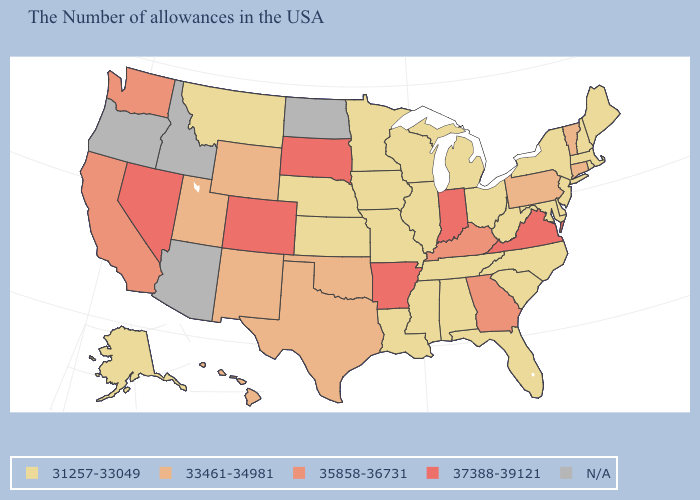Among the states that border West Virginia , does Virginia have the highest value?
Concise answer only. Yes. What is the value of Maryland?
Answer briefly. 31257-33049. How many symbols are there in the legend?
Be succinct. 5. Name the states that have a value in the range N/A?
Quick response, please. North Dakota, Arizona, Idaho, Oregon. What is the value of West Virginia?
Give a very brief answer. 31257-33049. What is the lowest value in the South?
Give a very brief answer. 31257-33049. What is the lowest value in the MidWest?
Quick response, please. 31257-33049. Does Pennsylvania have the highest value in the Northeast?
Quick response, please. Yes. What is the value of Arkansas?
Concise answer only. 37388-39121. Name the states that have a value in the range 31257-33049?
Quick response, please. Maine, Massachusetts, Rhode Island, New Hampshire, New York, New Jersey, Delaware, Maryland, North Carolina, South Carolina, West Virginia, Ohio, Florida, Michigan, Alabama, Tennessee, Wisconsin, Illinois, Mississippi, Louisiana, Missouri, Minnesota, Iowa, Kansas, Nebraska, Montana, Alaska. What is the value of Connecticut?
Quick response, please. 33461-34981. Does Mississippi have the highest value in the South?
Keep it brief. No. Does Montana have the lowest value in the West?
Be succinct. Yes. Does North Carolina have the highest value in the South?
Quick response, please. No. 